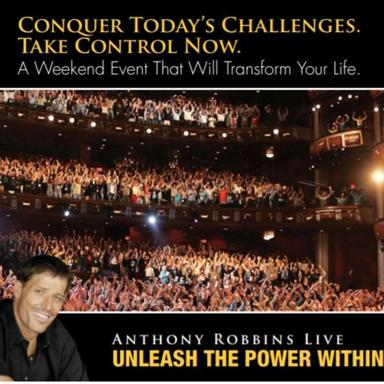What is the main goal of the event? The primary goal of 'Unleash the Power Within' is to offer participants strategies and psychological insights that empower them to take control of their emotional, physical, and financial destiny, thereby transforming their lives. 